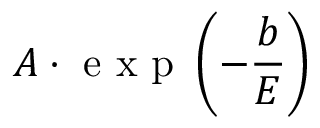<formula> <loc_0><loc_0><loc_500><loc_500>A \cdot e x p \left ( - \frac { b } { E } \right )</formula> 